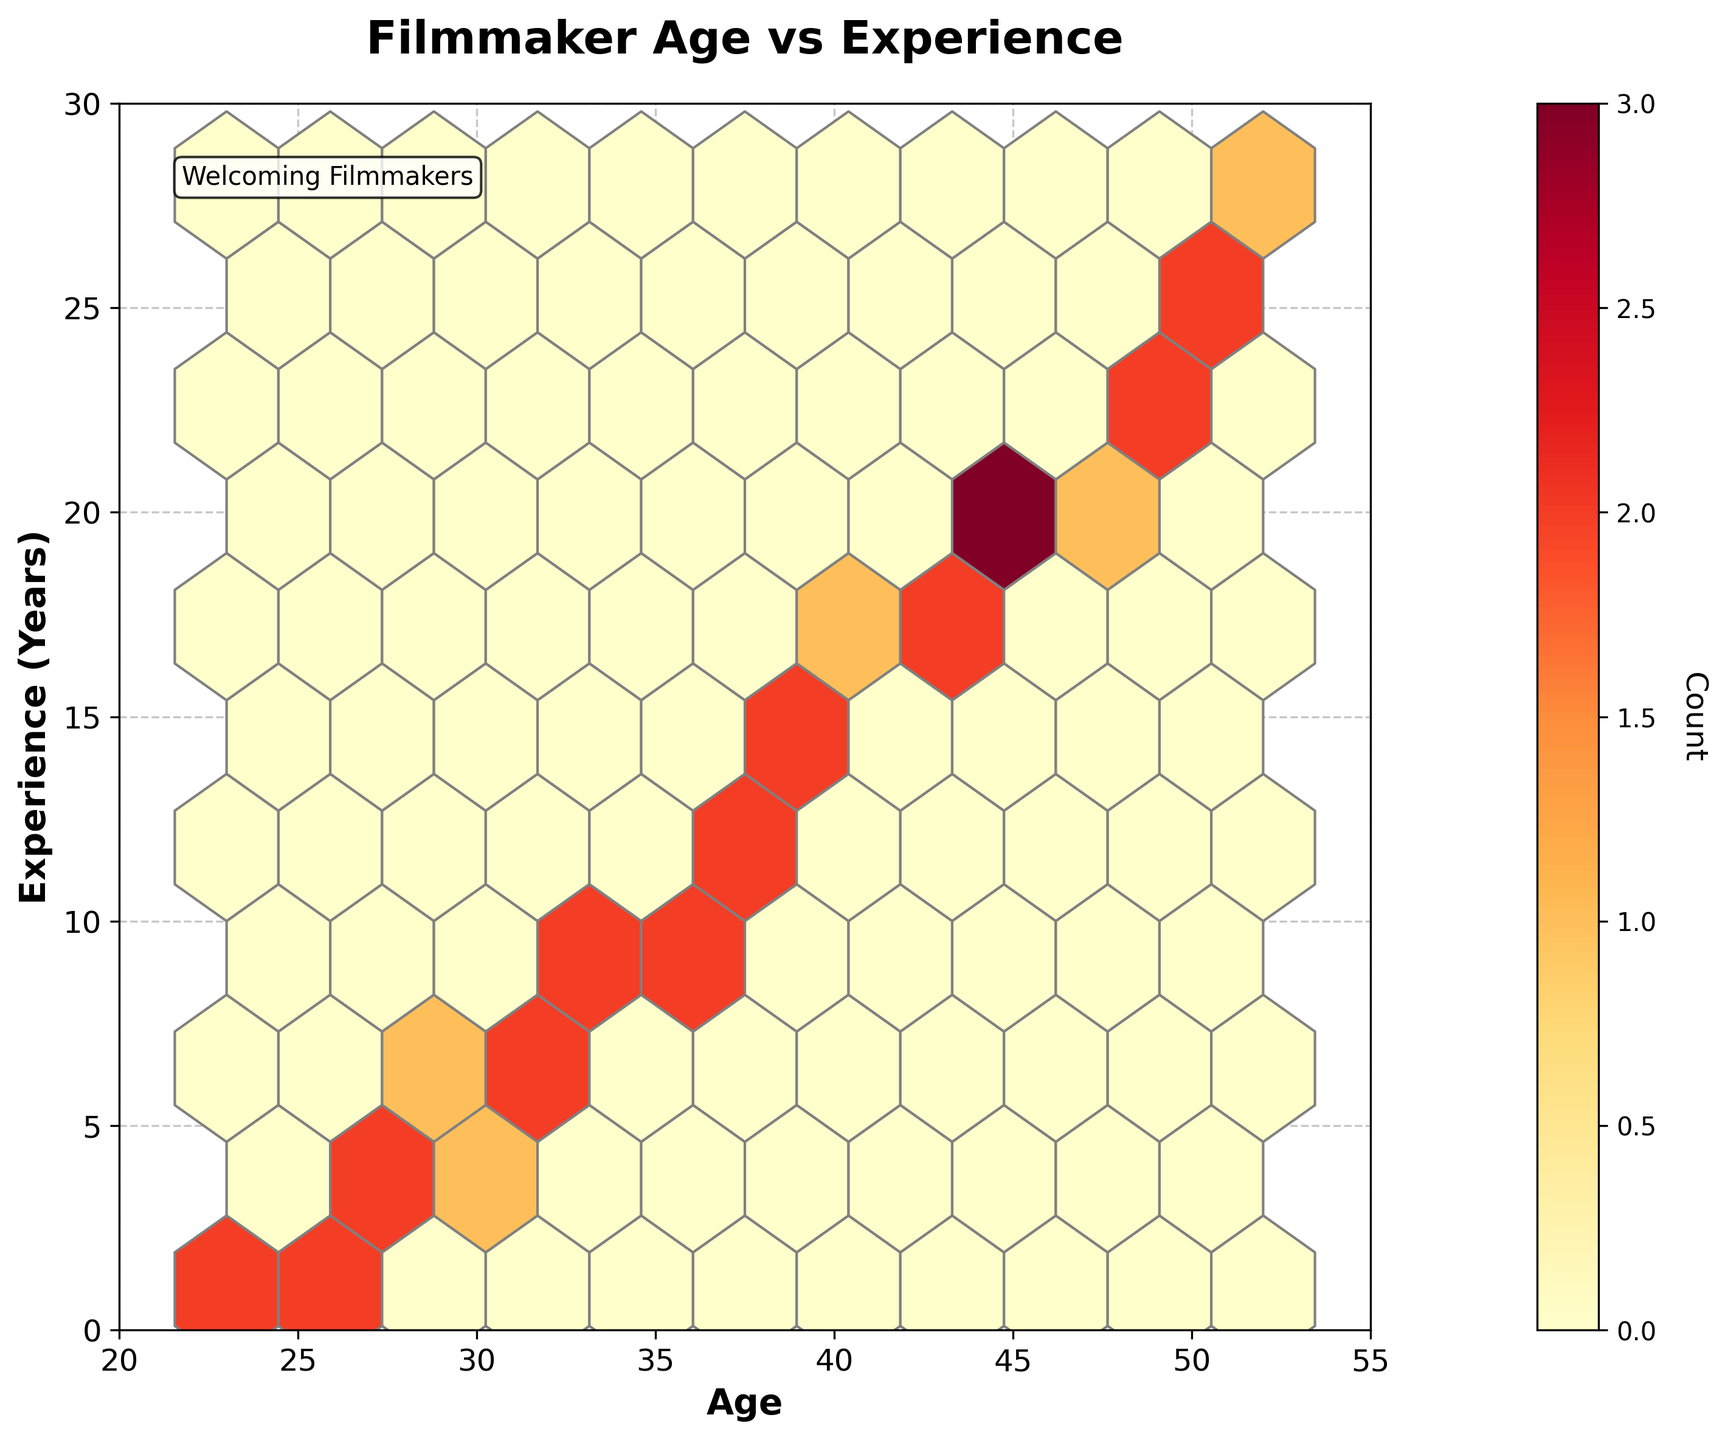How many data points fall within the age range of 20 to 30 years? By looking at the hexbin plot, we can count the dark and light-colored hexagons within the specified age range on the x-axis (20 to 30). Each hexagon represents one or more data points.
Answer: There are 9 data points What is the most common age-experience combination among the filmmakers? We can identify the combination by looking for the darkest hexagon since darker colors represent higher counts. Find the coordinates of this hexagon.
Answer: Age 35, Experience 10 years Which age group has a higher concentration of experienced filmmakers (over 20 years of experience), 40-45 or 45-50 years? Observe the hexagons in the specified age groups and count the ones with experience levels above 20 years on the y-axis. Compare their frequencies between the two age groups.
Answer: 45-50 years How does the experience distribution of filmmakers aged 30-35 compare to those aged 45-50? Check the hexagons for each age group. Note the spread and concentration of experience years within each age group. Age 30-35 should have more spread, while age 45-50 should have tighter clusters.
Answer: 30-35 is more spread out; 45-50 is more concentrated Are there more filmmakers with less than 10 years of experience or more than 20 years of experience? Tally the hexagons below the 10-year mark and those above the 20-year mark on the y-axis. The comparison will provide the majority group.
Answer: Less than 10 years Which age group spans the widest range of experience years? Identify the age range on the x-axis that has hexagons spread over the most extensive range of y-values (experience years).
Answer: Age 30-35 years What age range sees the highest concentration of over 15 years of experience? Look at the hexbin plot to see where the lighter and darker hexagons gather around the y-axis values above 15 years and note the age range on the x-axis.
Answer: Age 35-45 years Is there a greater range of ages in filmmakers with 20+ years of experience or those with less than 5 years? Compare the spread of hexagons on the x-axis for filmmakers above 20 years of experience and those below 5. For those with over 20 years, the ages should be more clustered. Less than 5 years should be more dispersed.
Answer: Less than 5 years 